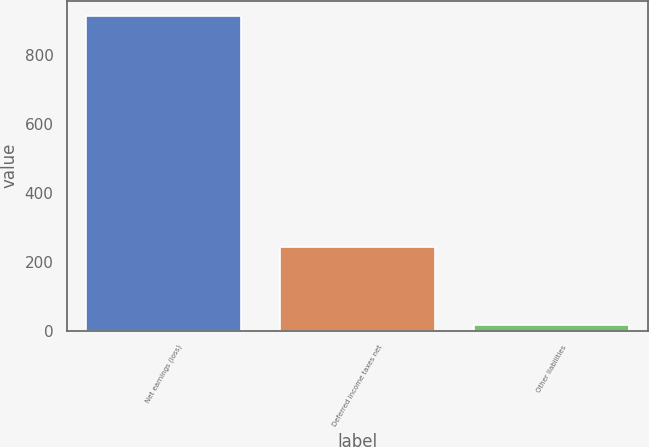Convert chart to OTSL. <chart><loc_0><loc_0><loc_500><loc_500><bar_chart><fcel>Net earnings (loss)<fcel>Deferred income taxes net<fcel>Other liabilities<nl><fcel>912<fcel>242<fcel>16<nl></chart> 